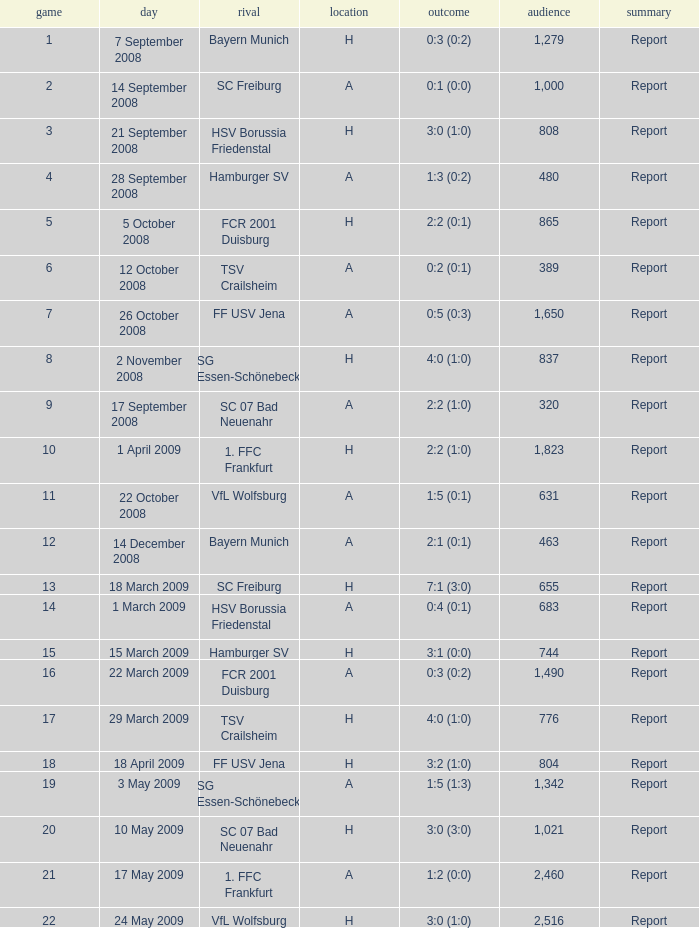Which match did FCR 2001 Duisburg participate as the opponent? 21.0. 